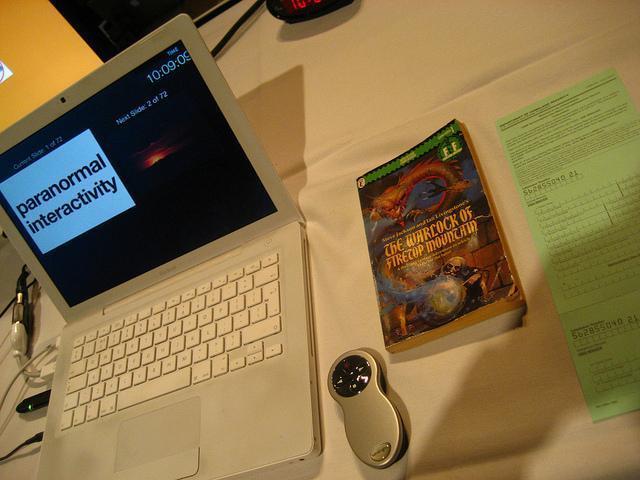How many remotes are seen?
Give a very brief answer. 1. How many batteries do you see?
Give a very brief answer. 0. How many computers are there?
Give a very brief answer. 1. How many books are in the picture?
Give a very brief answer. 1. 